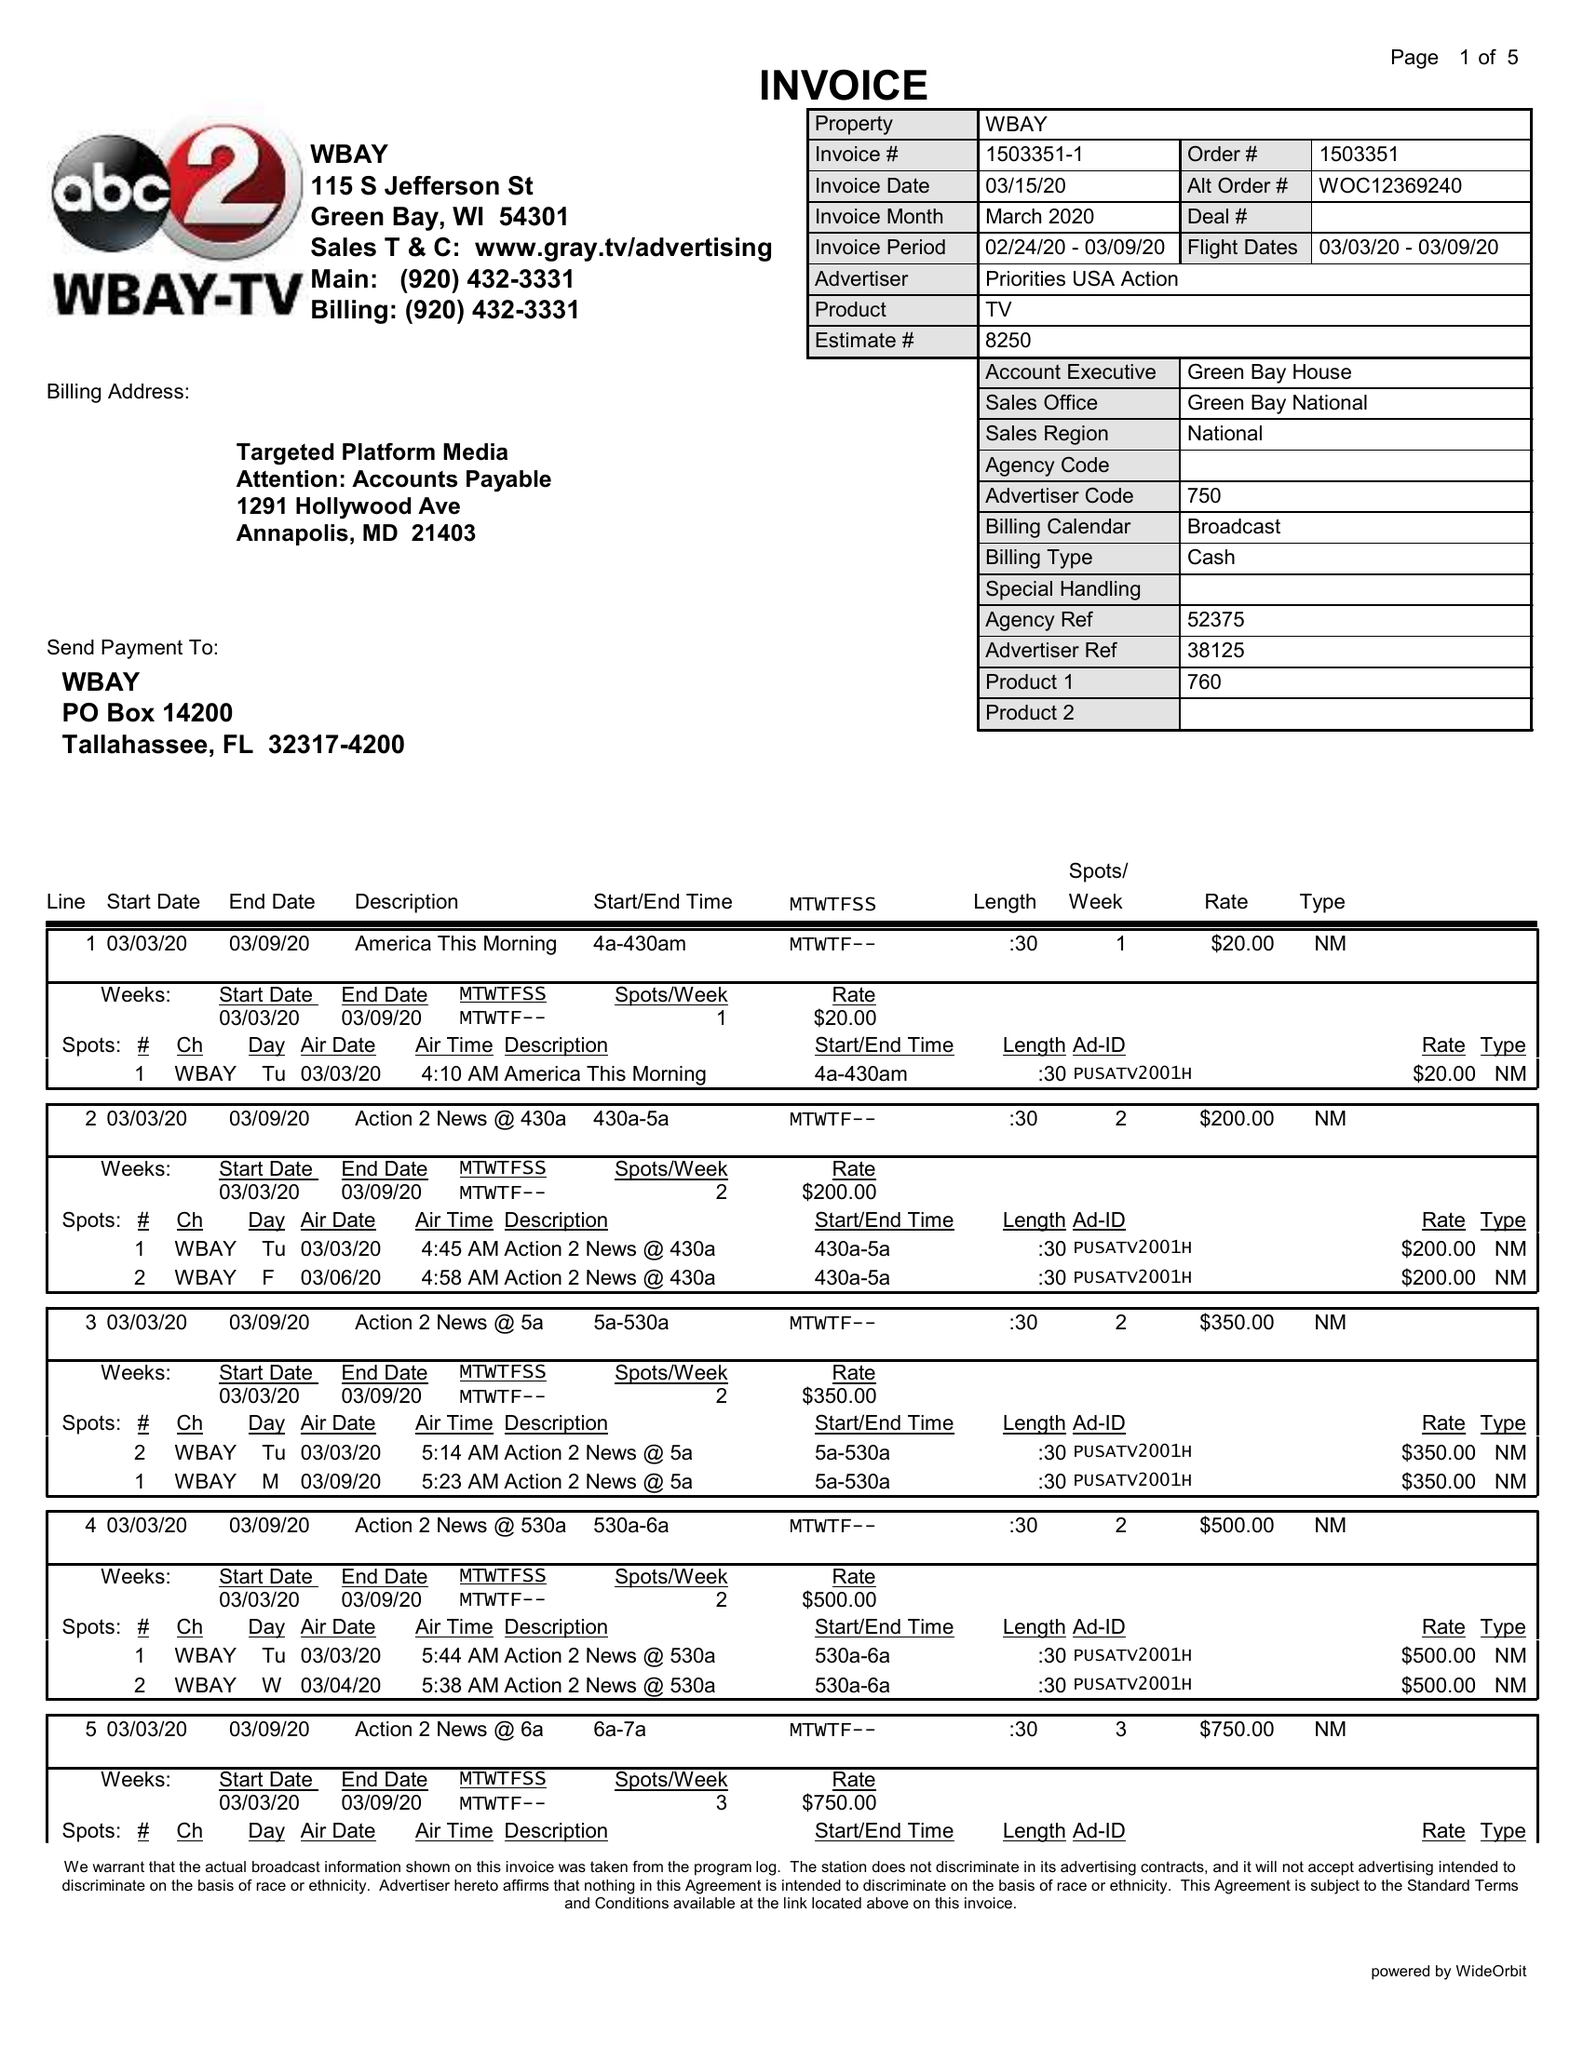What is the value for the contract_num?
Answer the question using a single word or phrase. 1503351 